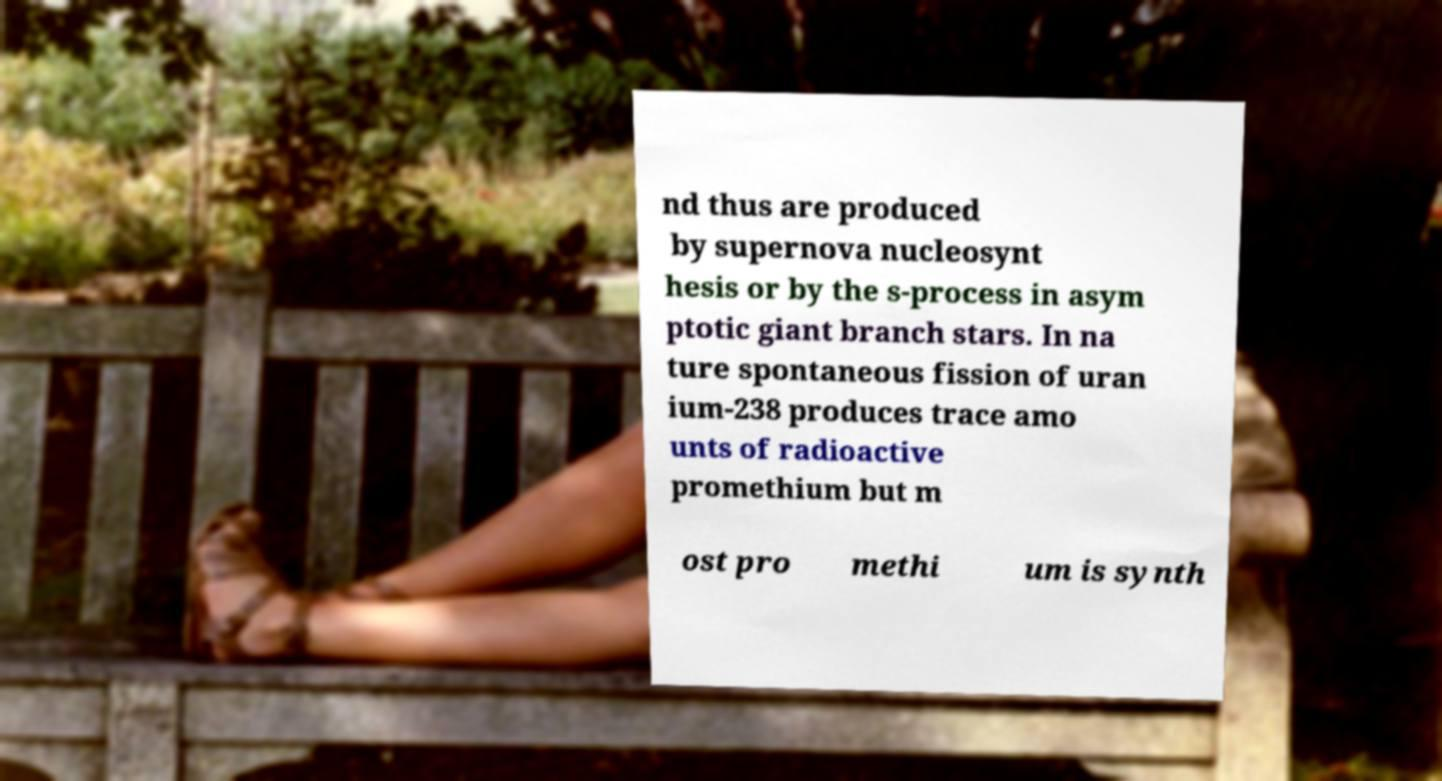Could you assist in decoding the text presented in this image and type it out clearly? nd thus are produced by supernova nucleosynt hesis or by the s-process in asym ptotic giant branch stars. In na ture spontaneous fission of uran ium-238 produces trace amo unts of radioactive promethium but m ost pro methi um is synth 